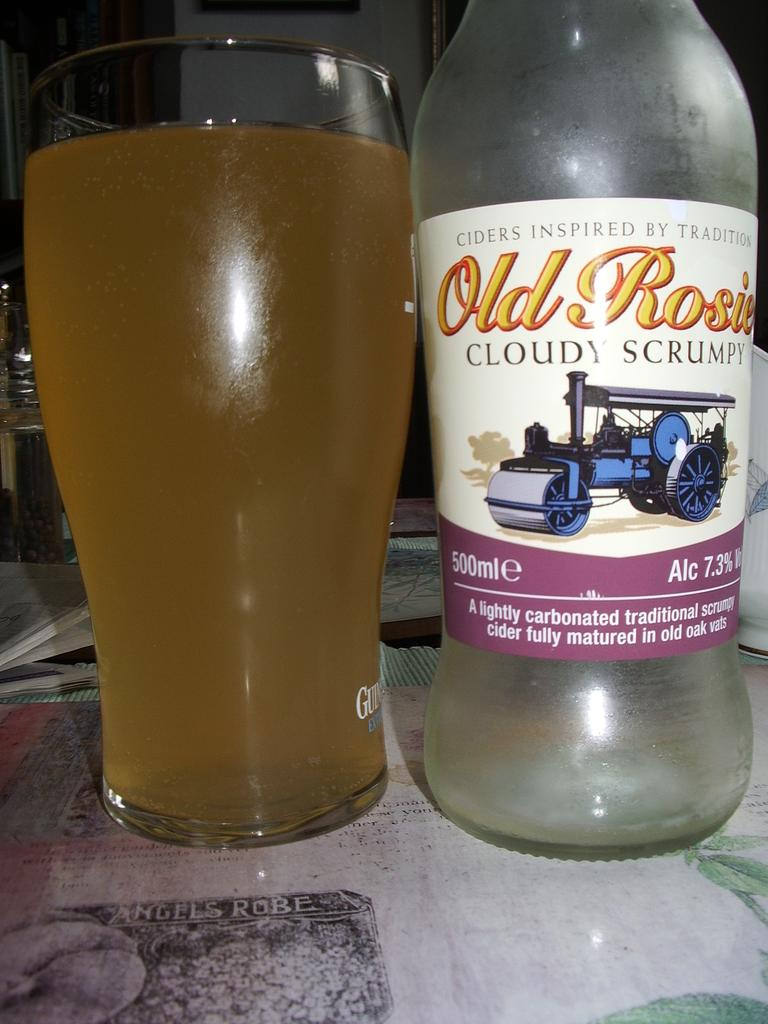<image>
Give a short and clear explanation of the subsequent image. The alcohol next to the glass is Old Rosie 